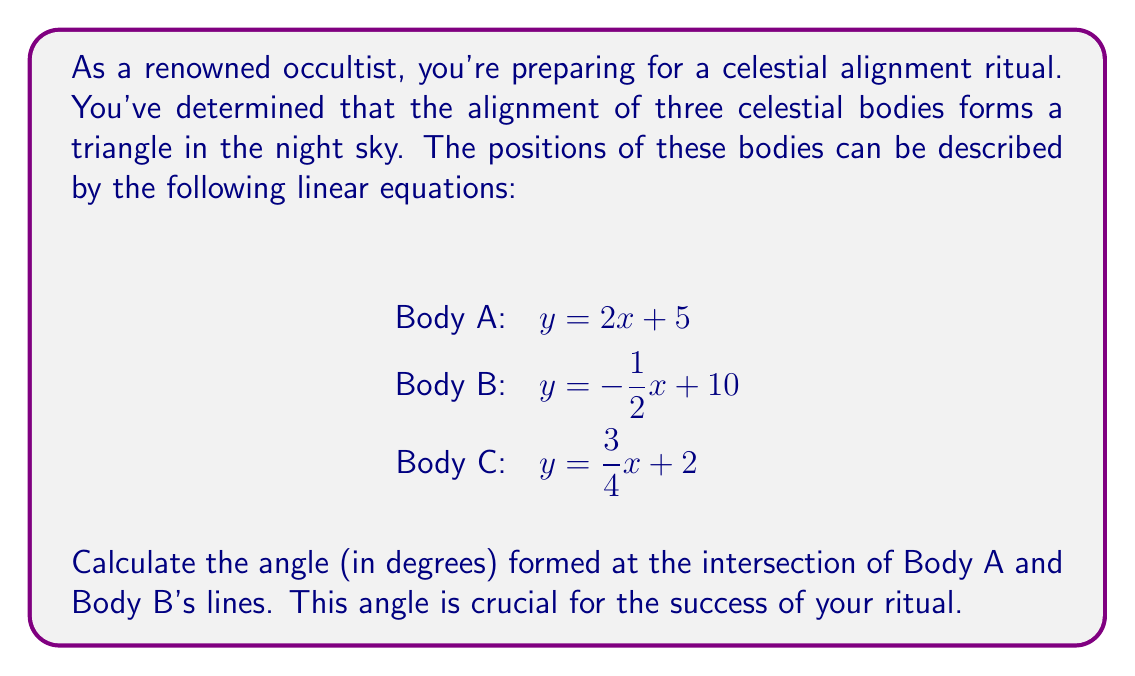Teach me how to tackle this problem. To find the angle between the lines representing Body A and Body B, we'll follow these steps:

1. First, we need to find the slopes of the two lines:
   For Body A: $m_1 = 2$
   For Body B: $m_2 = -\frac{1}{2}$

2. The angle between two lines can be calculated using the formula:
   $$\tan \theta = \left|\frac{m_1 - m_2}{1 + m_1m_2}\right|$$

3. Let's substitute our values:
   $$\tan \theta = \left|\frac{2 - (-\frac{1}{2})}{1 + 2(-\frac{1}{2})}\right| = \left|\frac{2 + \frac{1}{2}}{1 - 1}\right| = \left|\frac{\frac{5}{2}}{0}\right|$$

4. This results in an undefined value, which means the angle is 90°. This makes sense because the slopes are negative reciprocals of each other, indicating perpendicular lines.

5. To verify, we can calculate the product of the slopes:
   $m_1 \cdot m_2 = 2 \cdot (-\frac{1}{2}) = -1$
   When the product of two slopes is -1, the lines are perpendicular.

Therefore, the angle formed at the intersection of Body A and Body B's lines is 90°.
Answer: 90° 